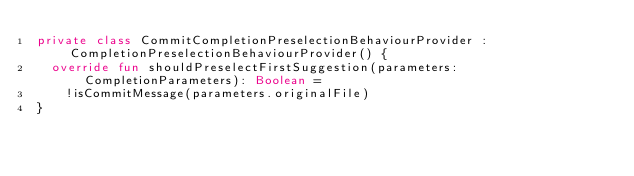<code> <loc_0><loc_0><loc_500><loc_500><_Kotlin_>private class CommitCompletionPreselectionBehaviourProvider : CompletionPreselectionBehaviourProvider() {
  override fun shouldPreselectFirstSuggestion(parameters: CompletionParameters): Boolean =
    !isCommitMessage(parameters.originalFile)
}</code> 